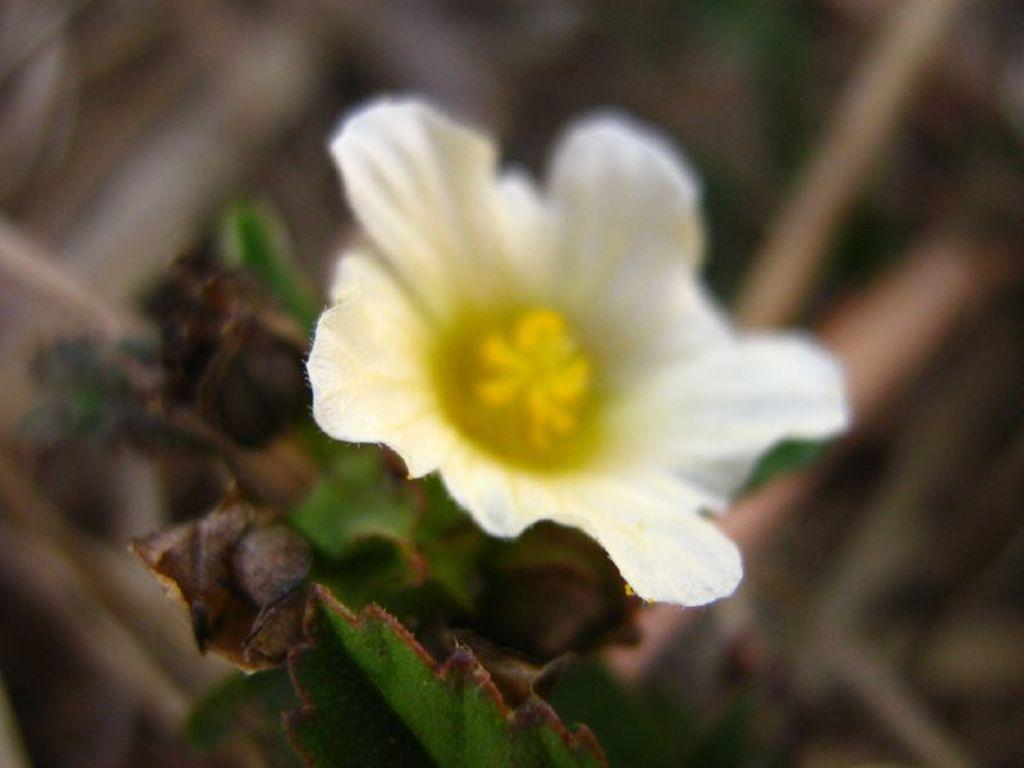What type of vegetation can be seen in the image? There are leaves in the image. What type of plant is also visible in the image? There is a flower in the image. What type of rod can be seen in the image? There is no rod present in the image. What day of the week is depicted in the image? The image does not depict a specific day of the week. What thoughts or ideas are being expressed by the leaves and flower in the image? The image does not convey any thoughts or ideas; it simply shows leaves and a flower. 